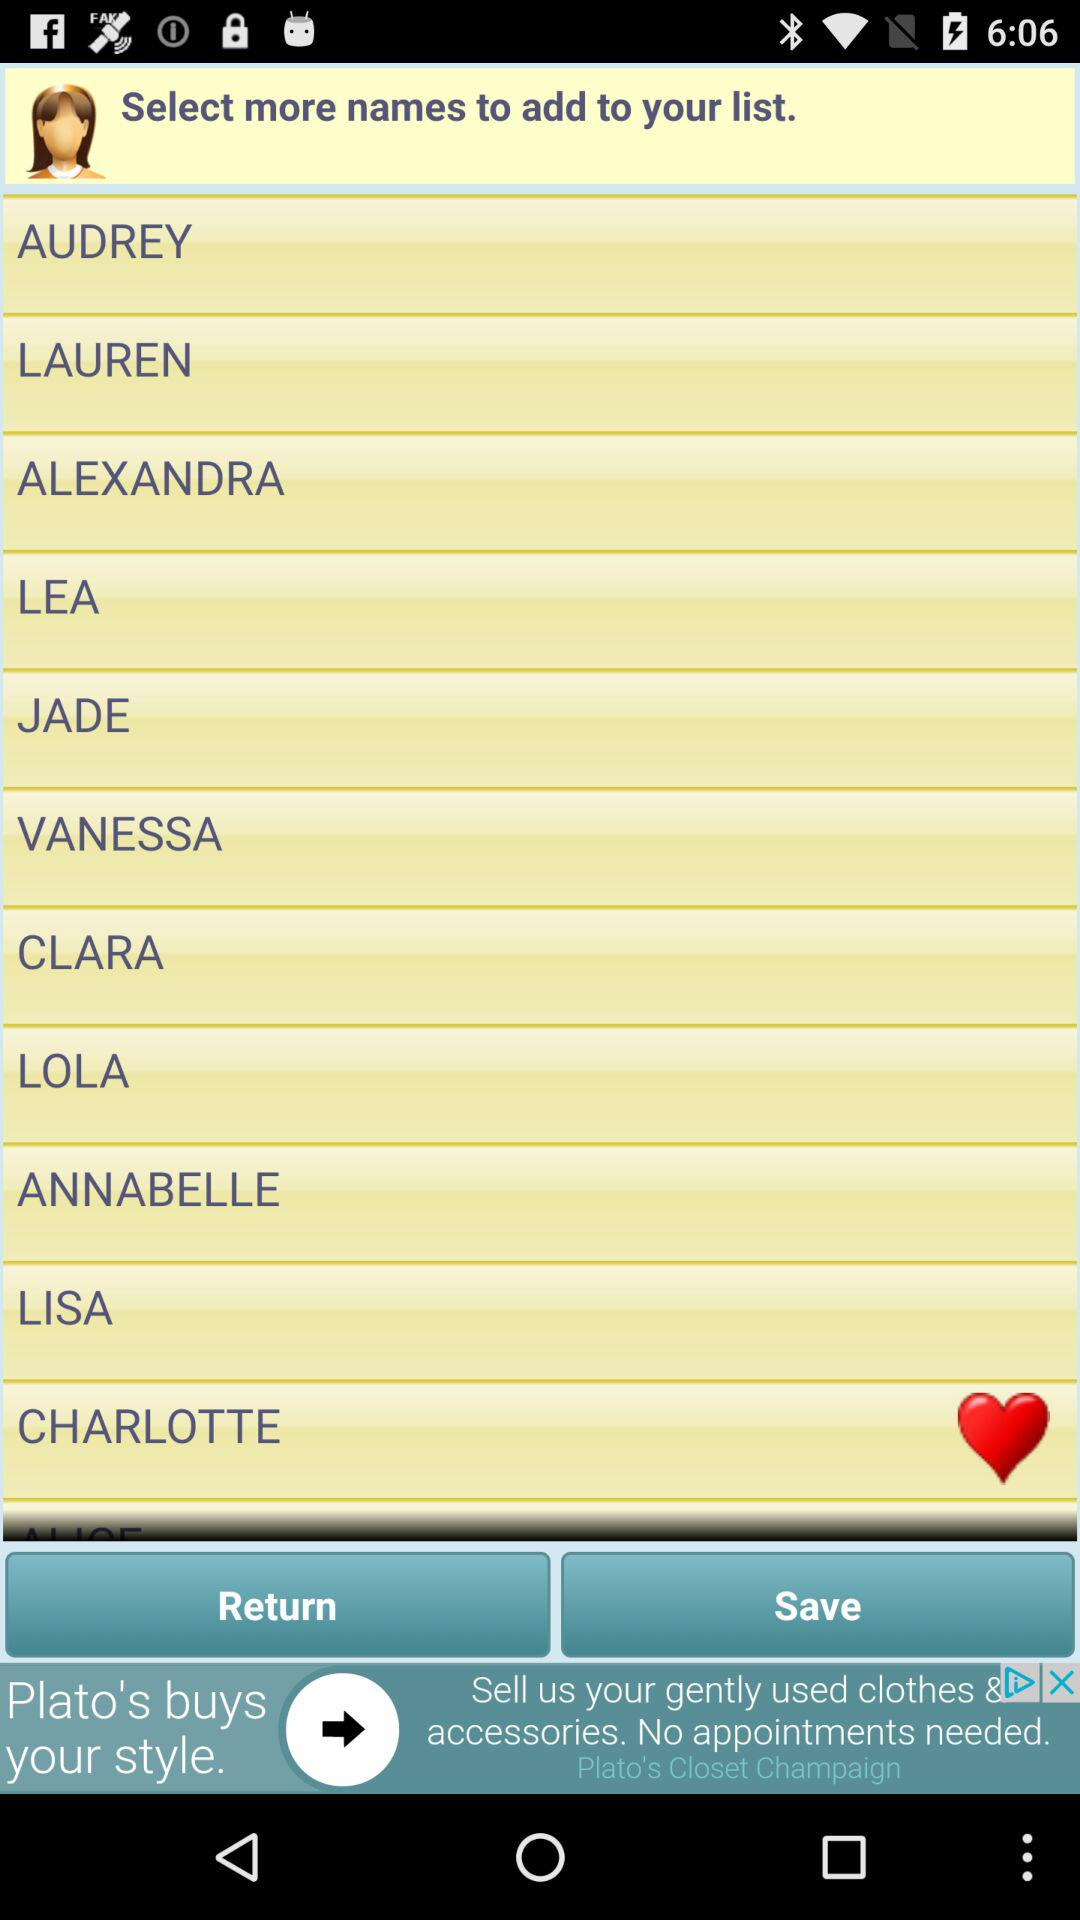What are the names on the list? The names on the list are Audrey, Lauren, Alexandra, Lea, Jade, Vanessa, Clara, Lola, Annabelle, Lisa and Charlotte. 